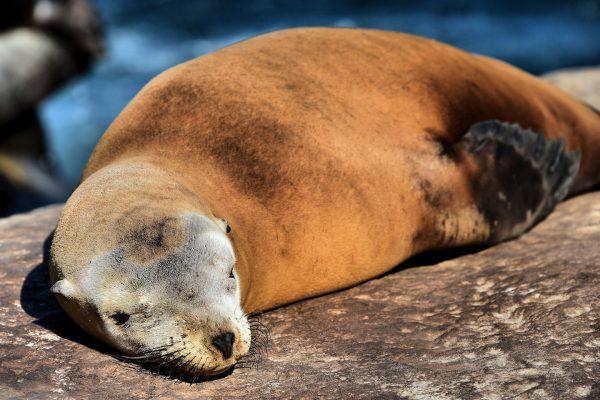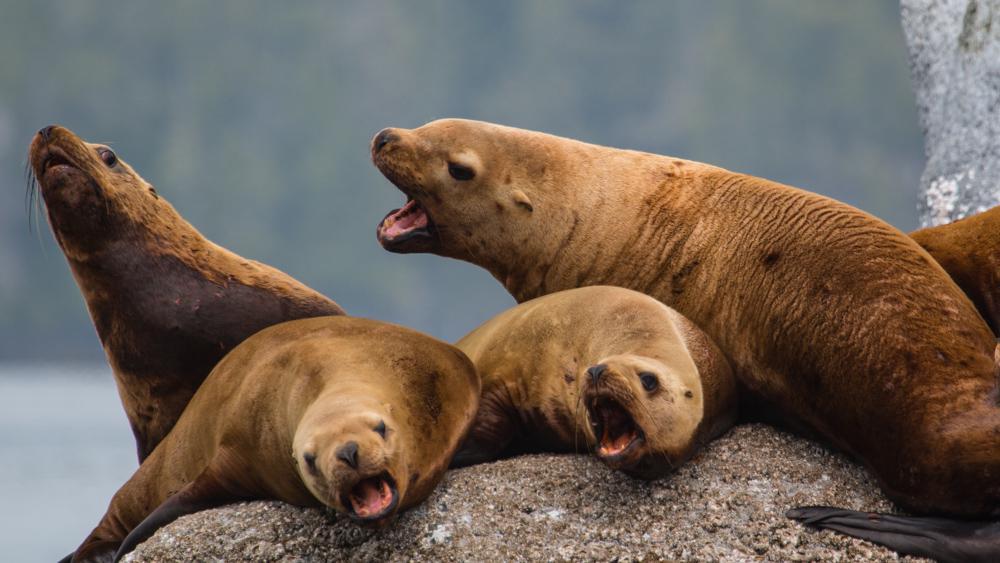The first image is the image on the left, the second image is the image on the right. For the images shown, is this caption "Left and right images show seals basking on rocks out of the water and include seals with their heads pointed toward the camera." true? Answer yes or no. Yes. The first image is the image on the left, the second image is the image on the right. For the images displayed, is the sentence "A single seal is sunning on a rock in the image on the left." factually correct? Answer yes or no. Yes. 